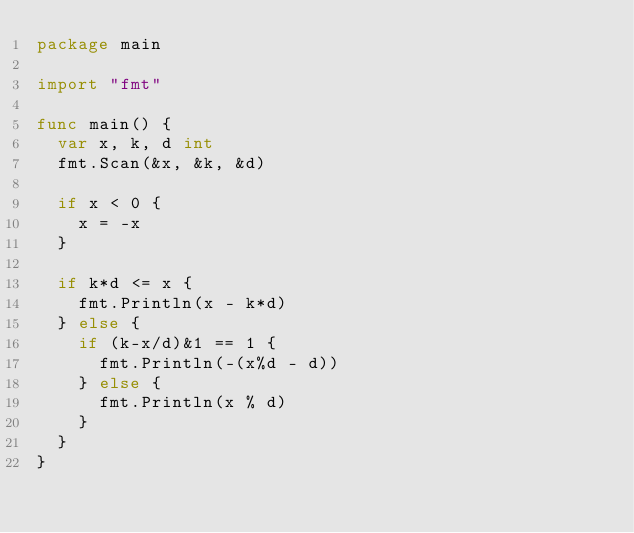<code> <loc_0><loc_0><loc_500><loc_500><_Go_>package main

import "fmt"

func main() {
	var x, k, d int
	fmt.Scan(&x, &k, &d)

	if x < 0 {
		x = -x
	}

	if k*d <= x {
		fmt.Println(x - k*d)
	} else {
		if (k-x/d)&1 == 1 {
			fmt.Println(-(x%d - d))
		} else {
			fmt.Println(x % d)
		}
	}
}
</code> 